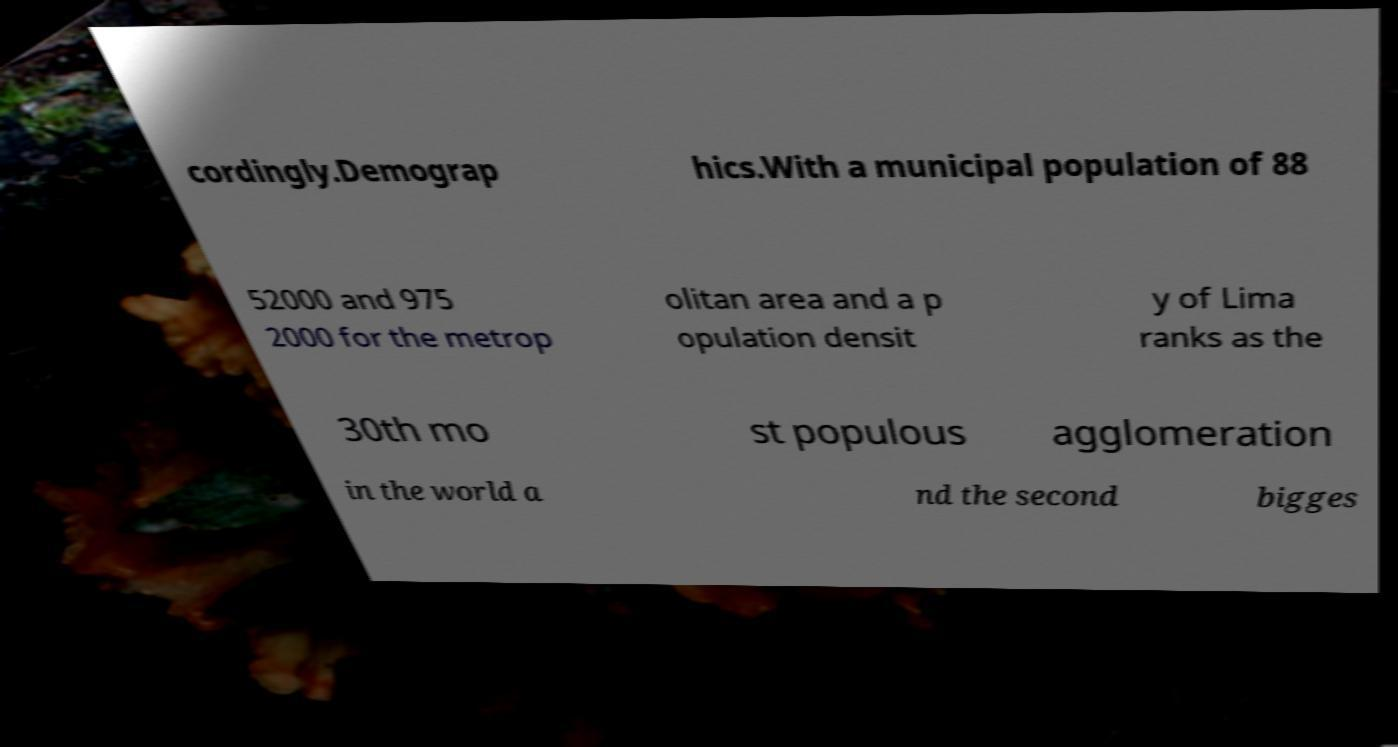Please identify and transcribe the text found in this image. cordingly.Demograp hics.With a municipal population of 88 52000 and 975 2000 for the metrop olitan area and a p opulation densit y of Lima ranks as the 30th mo st populous agglomeration in the world a nd the second bigges 